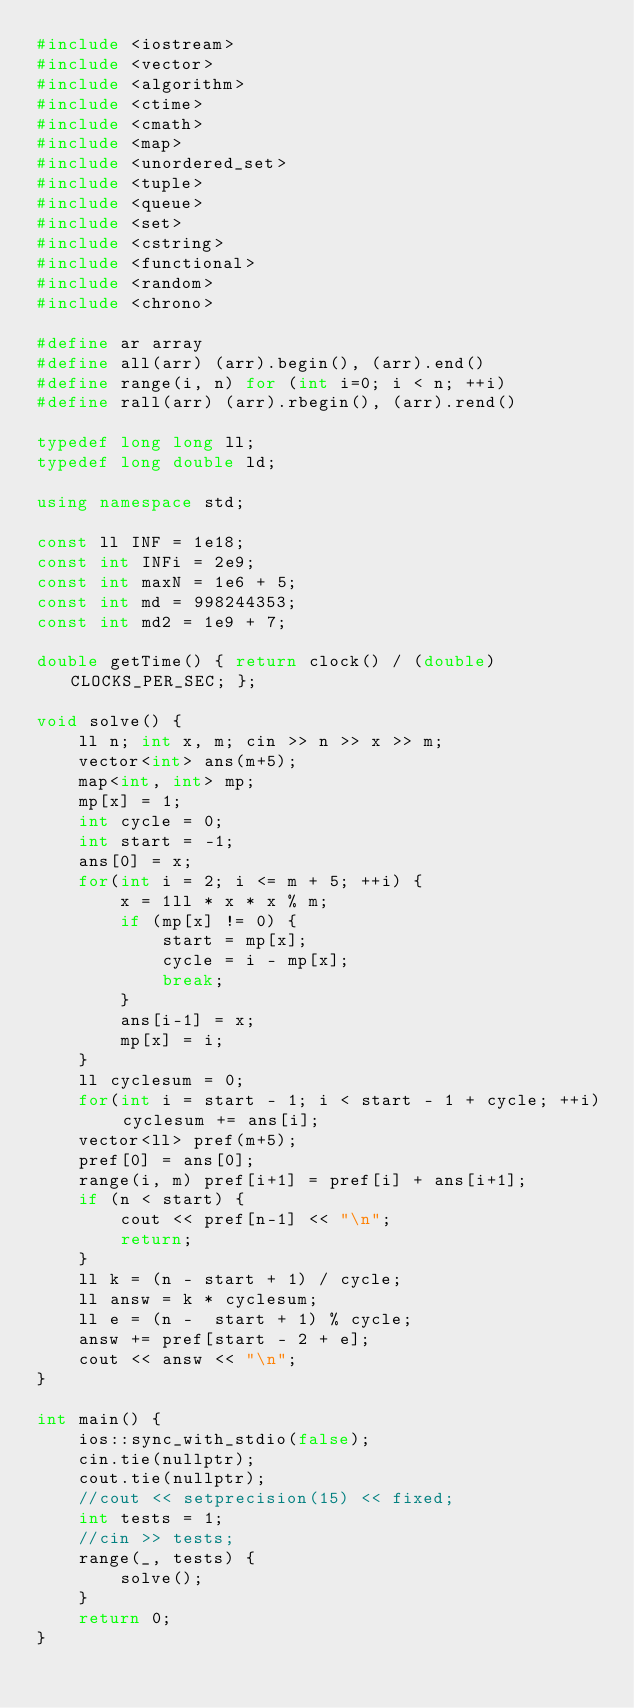<code> <loc_0><loc_0><loc_500><loc_500><_C++_>#include <iostream>
#include <vector>
#include <algorithm>
#include <ctime>
#include <cmath>
#include <map>
#include <unordered_set>
#include <tuple>
#include <queue>
#include <set>
#include <cstring>
#include <functional>
#include <random>
#include <chrono>

#define ar array
#define all(arr) (arr).begin(), (arr).end()
#define range(i, n) for (int i=0; i < n; ++i)
#define rall(arr) (arr).rbegin(), (arr).rend()

typedef long long ll;
typedef long double ld;

using namespace std;

const ll INF = 1e18;
const int INFi = 2e9;
const int maxN = 1e6 + 5;
const int md = 998244353;
const int md2 = 1e9 + 7;

double getTime() { return clock() / (double) CLOCKS_PER_SEC; };

void solve() {
    ll n; int x, m; cin >> n >> x >> m;
    vector<int> ans(m+5);
    map<int, int> mp;
    mp[x] = 1;
    int cycle = 0;
    int start = -1;
    ans[0] = x;
    for(int i = 2; i <= m + 5; ++i) {
        x = 1ll * x * x % m;
        if (mp[x] != 0) {
            start = mp[x];
            cycle = i - mp[x];
            break;
        }
        ans[i-1] = x;
        mp[x] = i;
    }
    ll cyclesum = 0;
    for(int i = start - 1; i < start - 1 + cycle; ++i) cyclesum += ans[i];
    vector<ll> pref(m+5);
    pref[0] = ans[0];
    range(i, m) pref[i+1] = pref[i] + ans[i+1];
    if (n < start) {
        cout << pref[n-1] << "\n";
        return;
    }
    ll k = (n - start + 1) / cycle;
    ll answ = k * cyclesum;
    ll e = (n -  start + 1) % cycle;
    answ += pref[start - 2 + e];
    cout << answ << "\n";
}

int main() {
    ios::sync_with_stdio(false);
    cin.tie(nullptr);
    cout.tie(nullptr);
    //cout << setprecision(15) << fixed;
    int tests = 1;
    //cin >> tests;
    range(_, tests) {
        solve();
    }
    return 0;
}</code> 